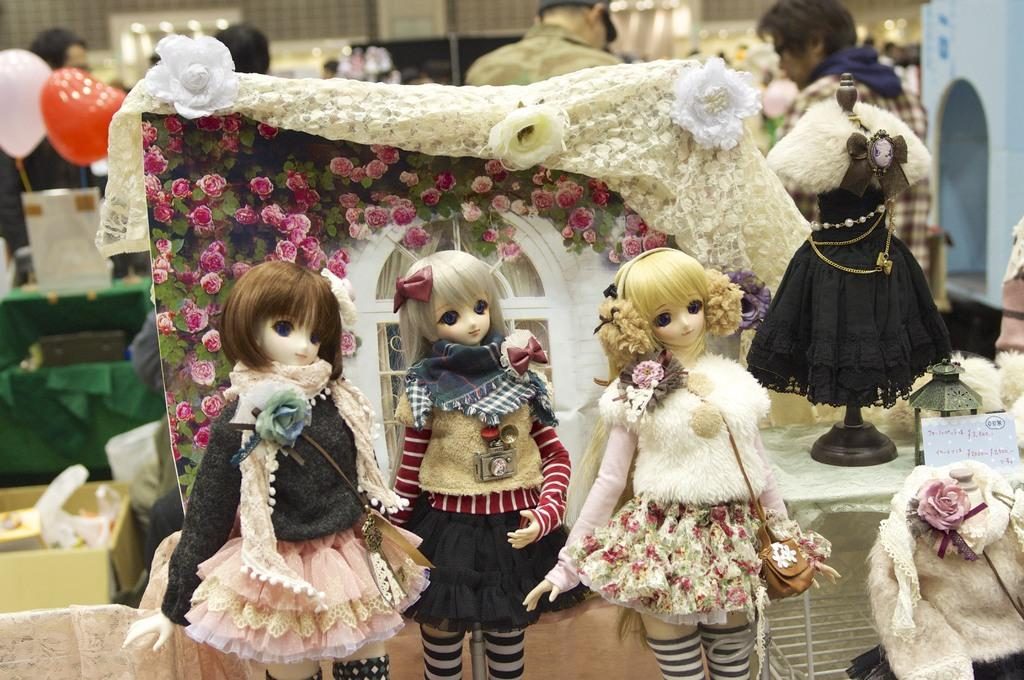What types of objects can be seen in the image? There are toys, posters, flowers, balloons, and candles in the image. What else can be found in the image? There are people present in the image. Can you describe the decorative elements in the image? The posters and balloons are decorative elements in the image. What other living organisms are present in the image besides people? There are no other living organisms besides people mentioned in the facts. How many locks can be seen securing the balloons in the image? There are no locks present in the image, so it is not possible to determine how many locks might be securing the balloons. 